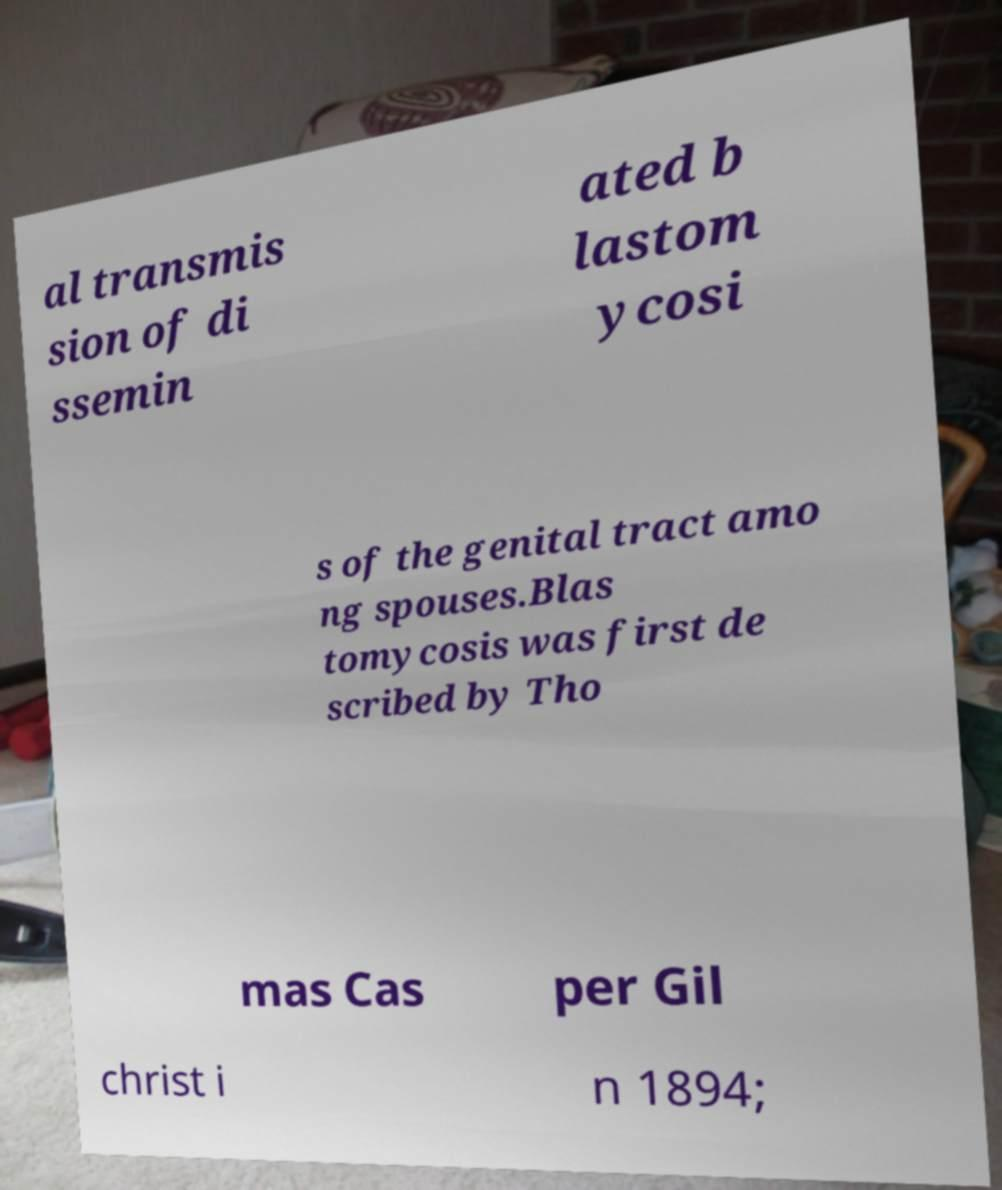There's text embedded in this image that I need extracted. Can you transcribe it verbatim? al transmis sion of di ssemin ated b lastom ycosi s of the genital tract amo ng spouses.Blas tomycosis was first de scribed by Tho mas Cas per Gil christ i n 1894; 